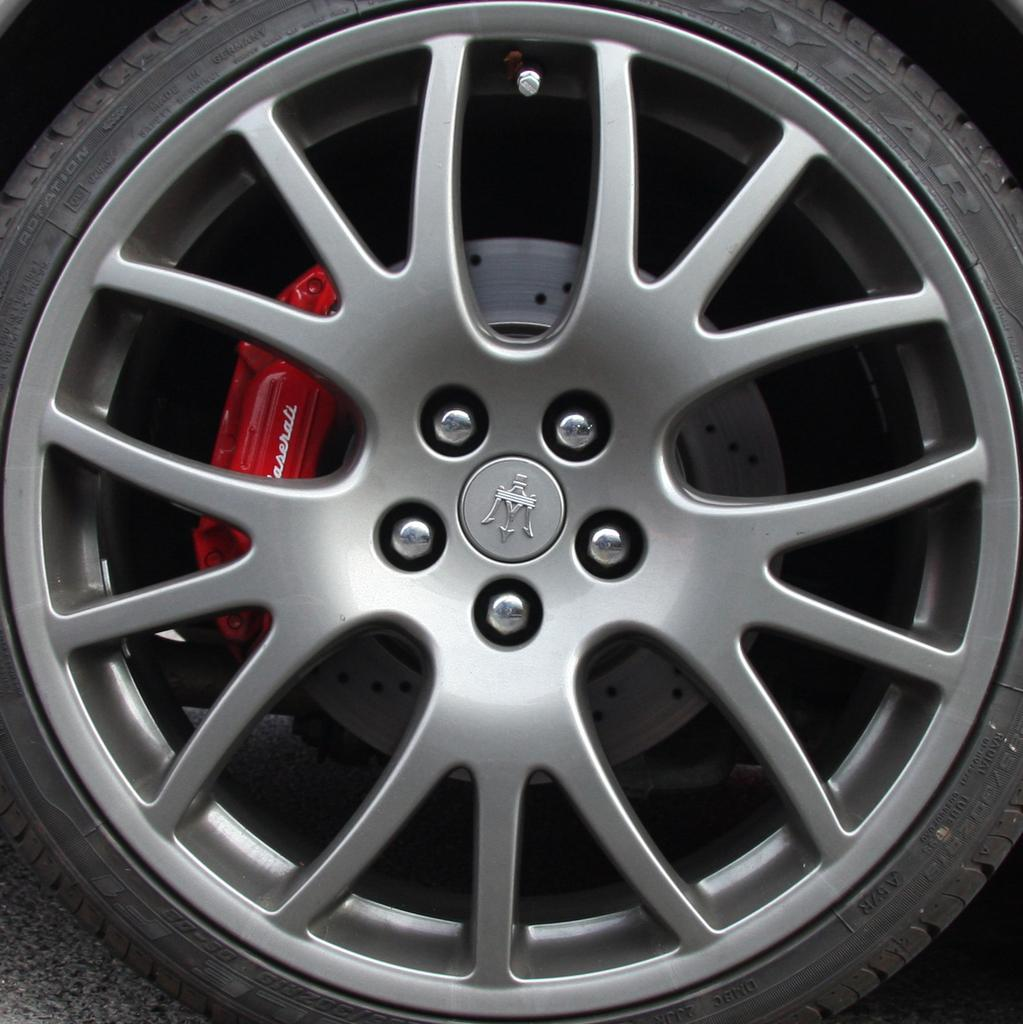What object related to a vehicle can be seen on the ground in the image? There is a wheel of a vehicle on the ground in the image. What other component related to the vehicle can be seen in the image? There is a brake pad visible in the image. What type of drink is being served in the image? There is no drink present in the image; it features a wheel of a vehicle and a brake pad. What emotion is being displayed by the vehicle in the image? Vehicles do not have emotions, so this question cannot be answered definitively from the image. 